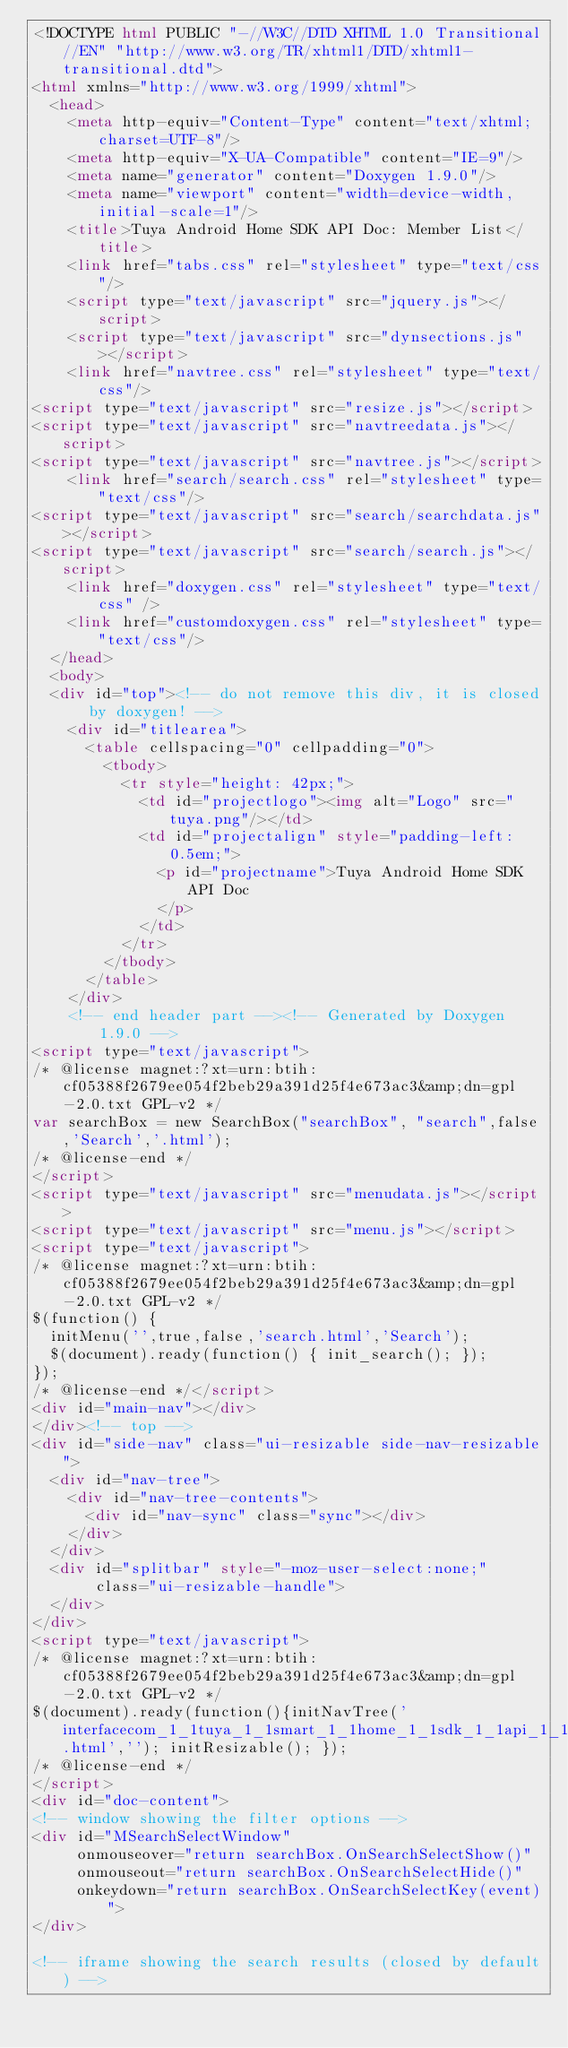Convert code to text. <code><loc_0><loc_0><loc_500><loc_500><_HTML_><!DOCTYPE html PUBLIC "-//W3C//DTD XHTML 1.0 Transitional//EN" "http://www.w3.org/TR/xhtml1/DTD/xhtml1-transitional.dtd">
<html xmlns="http://www.w3.org/1999/xhtml">
	<head>
		<meta http-equiv="Content-Type" content="text/xhtml;charset=UTF-8"/>
		<meta http-equiv="X-UA-Compatible" content="IE=9"/>
		<meta name="generator" content="Doxygen 1.9.0"/>
		<meta name="viewport" content="width=device-width, initial-scale=1"/>
		<title>Tuya Android Home SDK API Doc: Member List</title>
		<link href="tabs.css" rel="stylesheet" type="text/css"/>
		<script type="text/javascript" src="jquery.js"></script>
		<script type="text/javascript" src="dynsections.js"></script>
		<link href="navtree.css" rel="stylesheet" type="text/css"/>
<script type="text/javascript" src="resize.js"></script>
<script type="text/javascript" src="navtreedata.js"></script>
<script type="text/javascript" src="navtree.js"></script>
		<link href="search/search.css" rel="stylesheet" type="text/css"/>
<script type="text/javascript" src="search/searchdata.js"></script>
<script type="text/javascript" src="search/search.js"></script>
		<link href="doxygen.css" rel="stylesheet" type="text/css" />
		<link href="customdoxygen.css" rel="stylesheet" type="text/css"/>
	</head>
	<body>
	<div id="top"><!-- do not remove this div, it is closed by doxygen! -->
		<div id="titlearea">
			<table cellspacing="0" cellpadding="0">
				<tbody>
					<tr style="height: 42px;">
						<td id="projectlogo"><img alt="Logo" src="tuya.png"/></td>
						<td id="projectalign" style="padding-left: 0.5em;">
							<p id="projectname">Tuya Android Home SDK API Doc
							</p>
						</td>
					</tr>
				</tbody>
			</table>
		</div>
		<!-- end header part --><!-- Generated by Doxygen 1.9.0 -->
<script type="text/javascript">
/* @license magnet:?xt=urn:btih:cf05388f2679ee054f2beb29a391d25f4e673ac3&amp;dn=gpl-2.0.txt GPL-v2 */
var searchBox = new SearchBox("searchBox", "search",false,'Search','.html');
/* @license-end */
</script>
<script type="text/javascript" src="menudata.js"></script>
<script type="text/javascript" src="menu.js"></script>
<script type="text/javascript">
/* @license magnet:?xt=urn:btih:cf05388f2679ee054f2beb29a391d25f4e673ac3&amp;dn=gpl-2.0.txt GPL-v2 */
$(function() {
  initMenu('',true,false,'search.html','Search');
  $(document).ready(function() { init_search(); });
});
/* @license-end */</script>
<div id="main-nav"></div>
</div><!-- top -->
<div id="side-nav" class="ui-resizable side-nav-resizable">
  <div id="nav-tree">
    <div id="nav-tree-contents">
      <div id="nav-sync" class="sync"></div>
    </div>
  </div>
  <div id="splitbar" style="-moz-user-select:none;" 
       class="ui-resizable-handle">
  </div>
</div>
<script type="text/javascript">
/* @license magnet:?xt=urn:btih:cf05388f2679ee054f2beb29a391d25f4e673ac3&amp;dn=gpl-2.0.txt GPL-v2 */
$(document).ready(function(){initNavTree('interfacecom_1_1tuya_1_1smart_1_1home_1_1sdk_1_1api_1_1_i_tuya_lightning_searcher.html',''); initResizable(); });
/* @license-end */
</script>
<div id="doc-content">
<!-- window showing the filter options -->
<div id="MSearchSelectWindow"
     onmouseover="return searchBox.OnSearchSelectShow()"
     onmouseout="return searchBox.OnSearchSelectHide()"
     onkeydown="return searchBox.OnSearchSelectKey(event)">
</div>

<!-- iframe showing the search results (closed by default) --></code> 